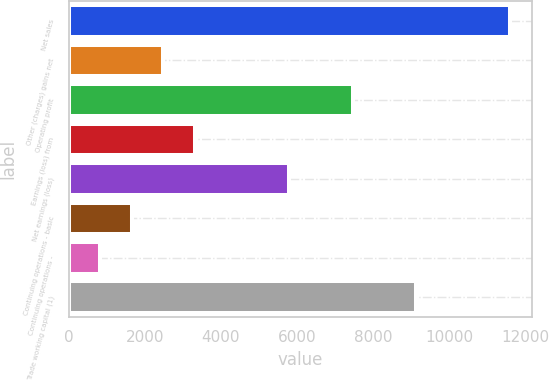Convert chart to OTSL. <chart><loc_0><loc_0><loc_500><loc_500><bar_chart><fcel>Net sales<fcel>Other (charges) gains net<fcel>Operating profit<fcel>Earnings (loss) from<fcel>Net earnings (loss)<fcel>Continuing operations - basic<fcel>Continuing operations -<fcel>Trade working capital (1)<nl><fcel>11593.3<fcel>2484.42<fcel>7452.9<fcel>3312.5<fcel>5796.74<fcel>1656.34<fcel>828.26<fcel>9109.06<nl></chart> 